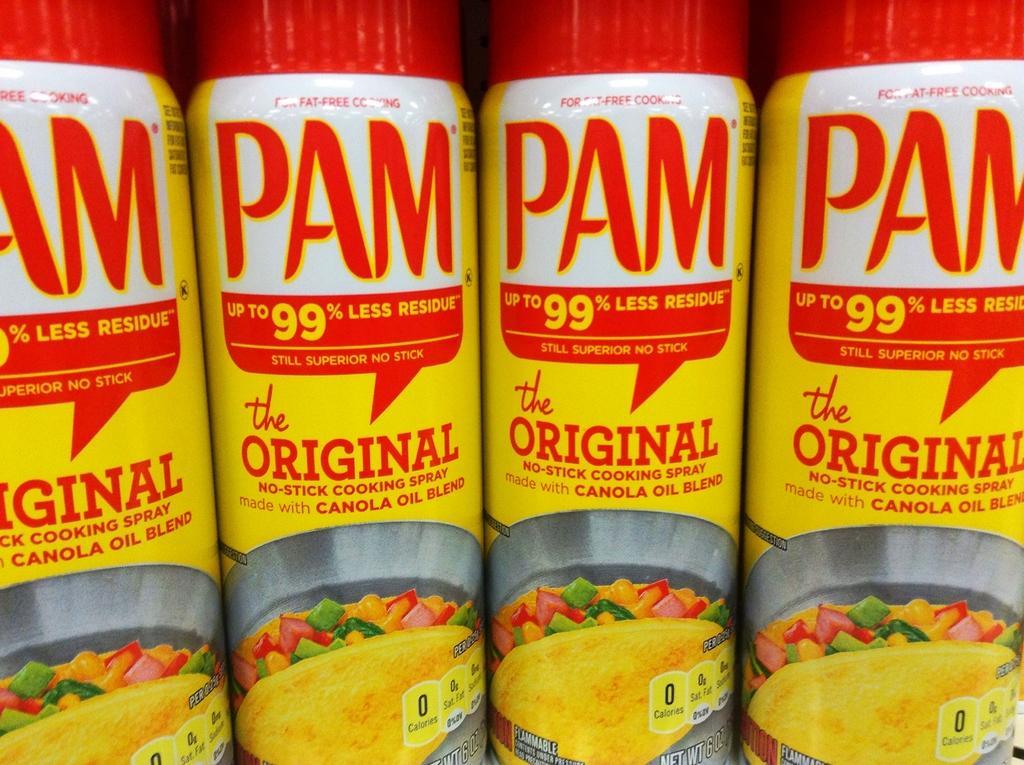Could you give a brief overview of what you see in this image? In this image there are some objects placed in the shelf's. 